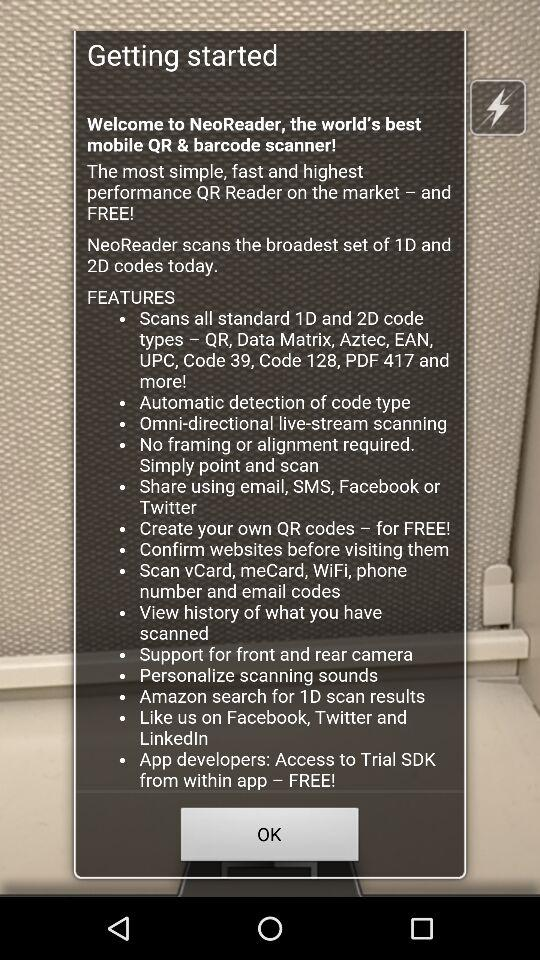Which camera can support the application?
When the provided information is insufficient, respond with <no answer>. <no answer> 